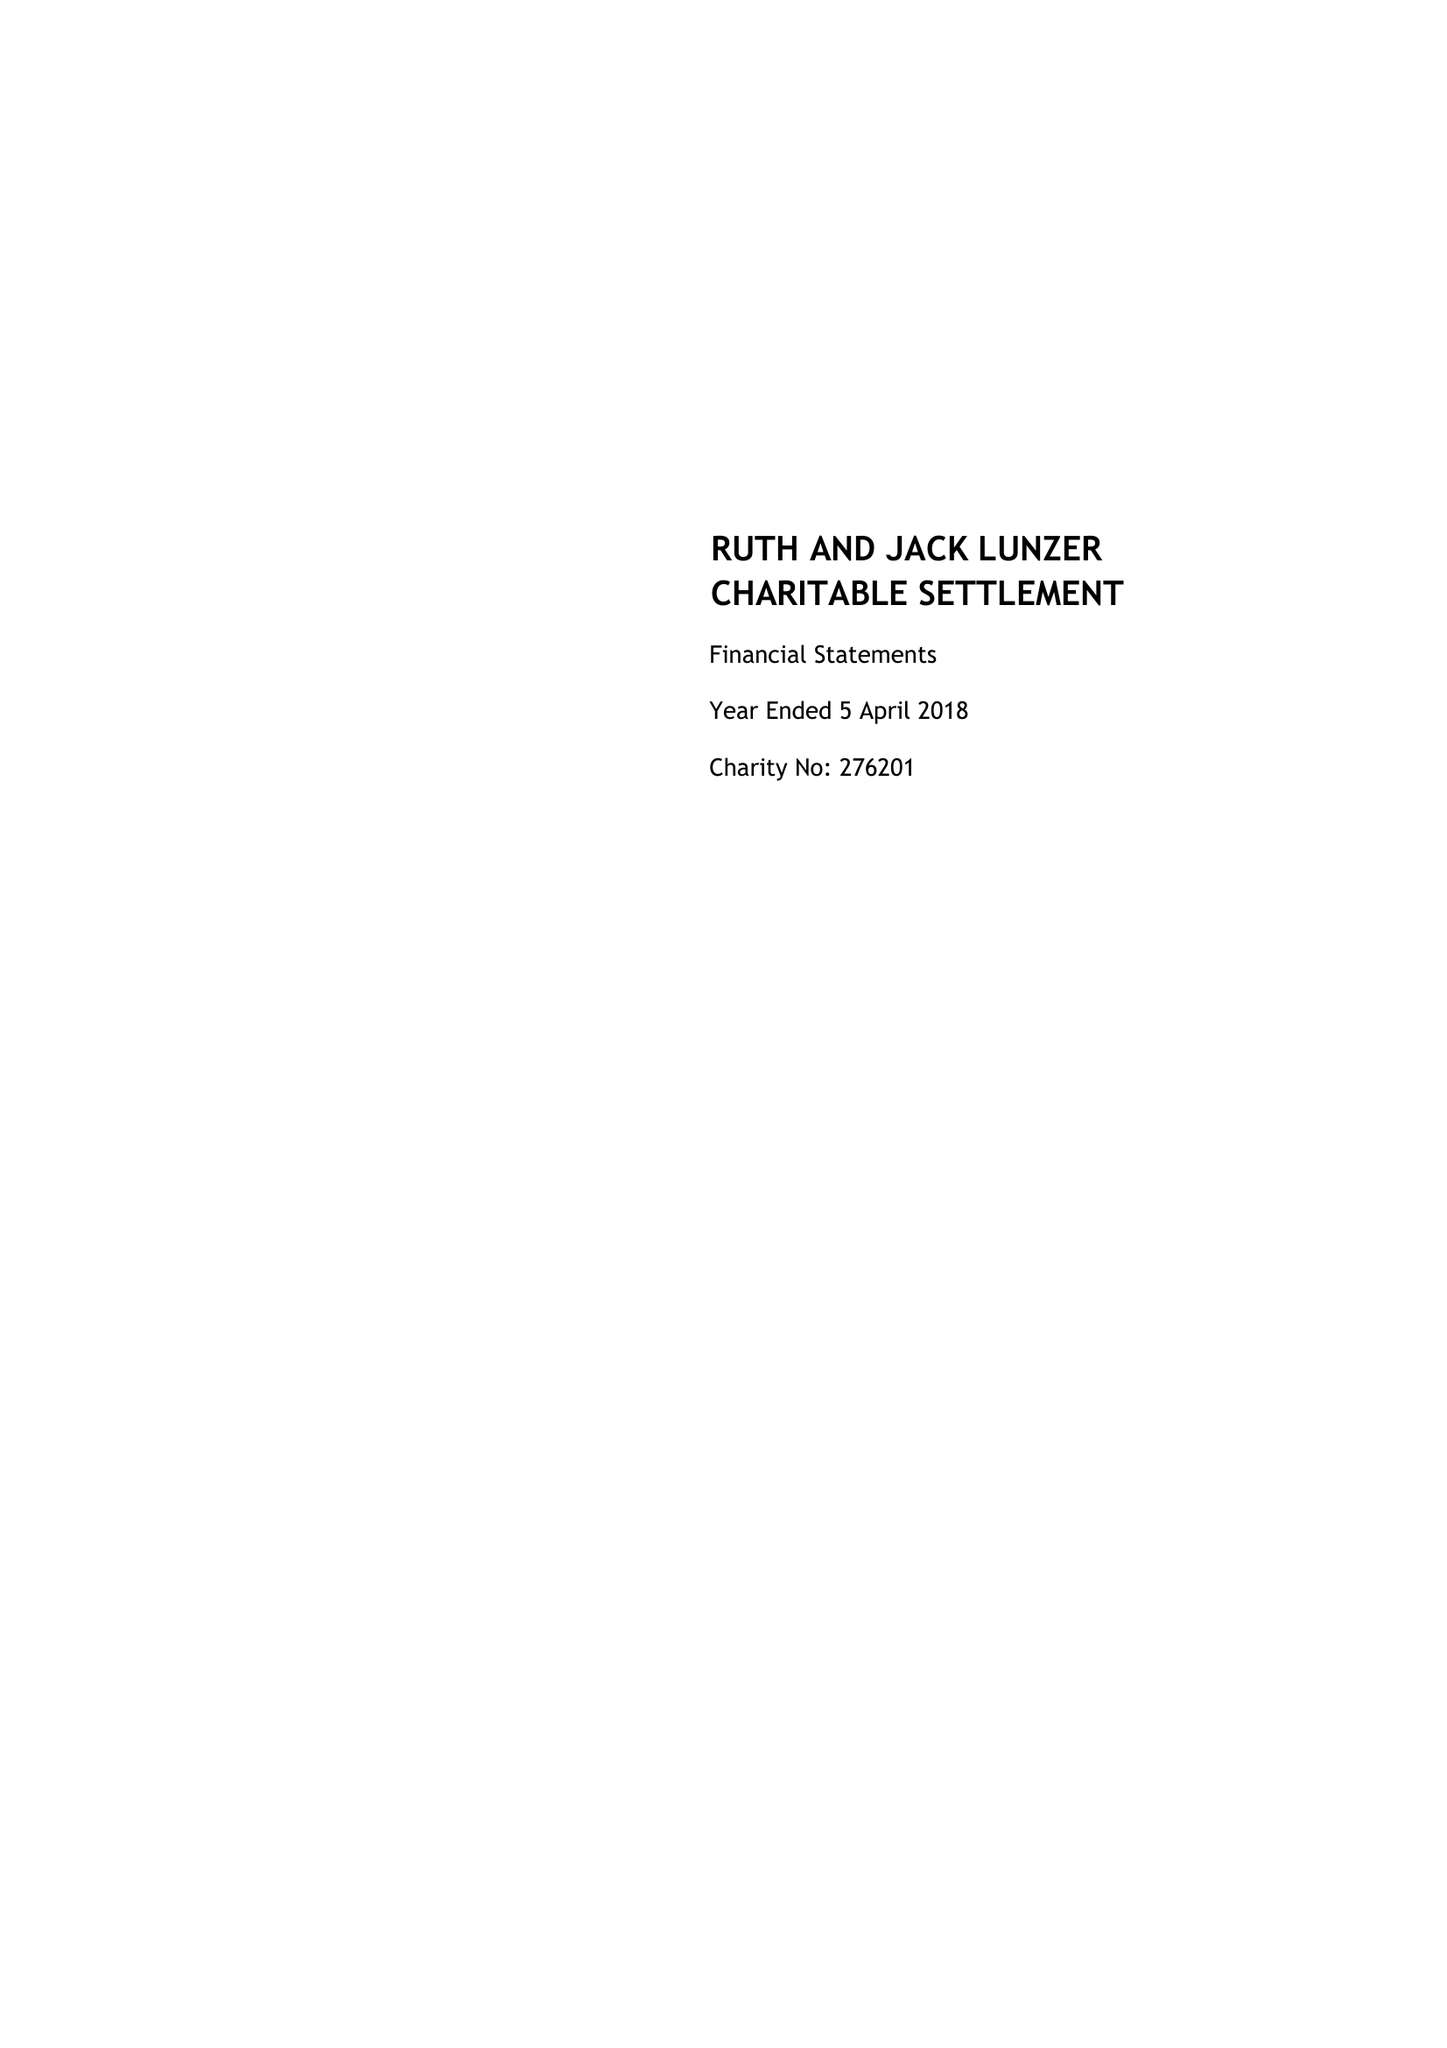What is the value for the address__street_line?
Answer the question using a single word or phrase. None 